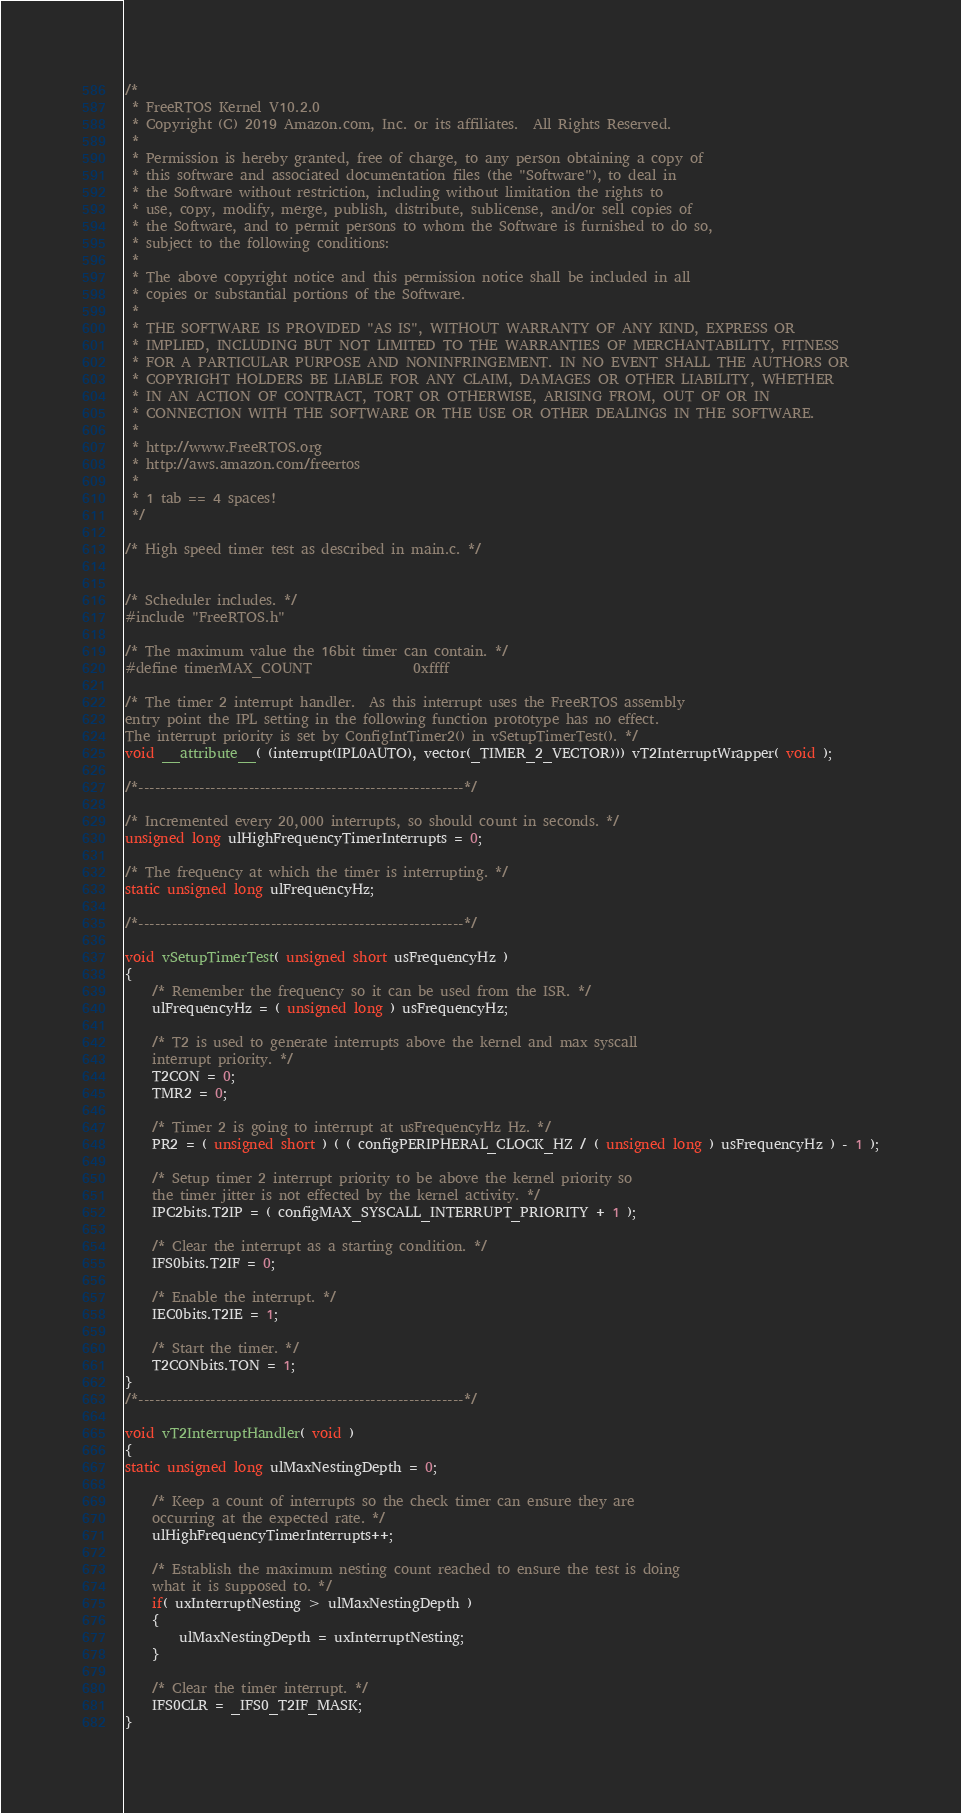Convert code to text. <code><loc_0><loc_0><loc_500><loc_500><_C_>/*
 * FreeRTOS Kernel V10.2.0
 * Copyright (C) 2019 Amazon.com, Inc. or its affiliates.  All Rights Reserved.
 *
 * Permission is hereby granted, free of charge, to any person obtaining a copy of
 * this software and associated documentation files (the "Software"), to deal in
 * the Software without restriction, including without limitation the rights to
 * use, copy, modify, merge, publish, distribute, sublicense, and/or sell copies of
 * the Software, and to permit persons to whom the Software is furnished to do so,
 * subject to the following conditions:
 *
 * The above copyright notice and this permission notice shall be included in all
 * copies or substantial portions of the Software.
 *
 * THE SOFTWARE IS PROVIDED "AS IS", WITHOUT WARRANTY OF ANY KIND, EXPRESS OR
 * IMPLIED, INCLUDING BUT NOT LIMITED TO THE WARRANTIES OF MERCHANTABILITY, FITNESS
 * FOR A PARTICULAR PURPOSE AND NONINFRINGEMENT. IN NO EVENT SHALL THE AUTHORS OR
 * COPYRIGHT HOLDERS BE LIABLE FOR ANY CLAIM, DAMAGES OR OTHER LIABILITY, WHETHER
 * IN AN ACTION OF CONTRACT, TORT OR OTHERWISE, ARISING FROM, OUT OF OR IN
 * CONNECTION WITH THE SOFTWARE OR THE USE OR OTHER DEALINGS IN THE SOFTWARE.
 *
 * http://www.FreeRTOS.org
 * http://aws.amazon.com/freertos
 *
 * 1 tab == 4 spaces!
 */

/* High speed timer test as described in main.c. */


/* Scheduler includes. */
#include "FreeRTOS.h"

/* The maximum value the 16bit timer can contain. */
#define timerMAX_COUNT				0xffff

/* The timer 2 interrupt handler.  As this interrupt uses the FreeRTOS assembly
entry point the IPL setting in the following function prototype has no effect.
The interrupt priority is set by ConfigIntTimer2() in vSetupTimerTest(). */
void __attribute__( (interrupt(IPL0AUTO), vector(_TIMER_2_VECTOR))) vT2InterruptWrapper( void );

/*-----------------------------------------------------------*/

/* Incremented every 20,000 interrupts, so should count in seconds. */
unsigned long ulHighFrequencyTimerInterrupts = 0;

/* The frequency at which the timer is interrupting. */
static unsigned long ulFrequencyHz;

/*-----------------------------------------------------------*/

void vSetupTimerTest( unsigned short usFrequencyHz )
{
	/* Remember the frequency so it can be used from the ISR. */
	ulFrequencyHz = ( unsigned long ) usFrequencyHz;

	/* T2 is used to generate interrupts above the kernel and max syscall 
	interrupt priority. */
	T2CON = 0;
	TMR2 = 0;

	/* Timer 2 is going to interrupt at usFrequencyHz Hz. */
	PR2 = ( unsigned short ) ( ( configPERIPHERAL_CLOCK_HZ / ( unsigned long ) usFrequencyHz ) - 1 );

	/* Setup timer 2 interrupt priority to be above the kernel priority so
	the timer jitter is not effected by the kernel activity. */
	IPC2bits.T2IP = ( configMAX_SYSCALL_INTERRUPT_PRIORITY + 1 );

	/* Clear the interrupt as a starting condition. */
	IFS0bits.T2IF = 0;

	/* Enable the interrupt. */
	IEC0bits.T2IE = 1;

	/* Start the timer. */
	T2CONbits.TON = 1;
}
/*-----------------------------------------------------------*/

void vT2InterruptHandler( void )
{
static unsigned long ulMaxNestingDepth = 0;

	/* Keep a count of interrupts so the check timer can ensure they are
	occurring at the expected rate. */
	ulHighFrequencyTimerInterrupts++;

	/* Establish the maximum nesting count reached to ensure the test is doing
	what it is supposed to. */
	if( uxInterruptNesting > ulMaxNestingDepth )
	{
		ulMaxNestingDepth = uxInterruptNesting;
	}

	/* Clear the timer interrupt. */
	IFS0CLR = _IFS0_T2IF_MASK;
}


</code> 